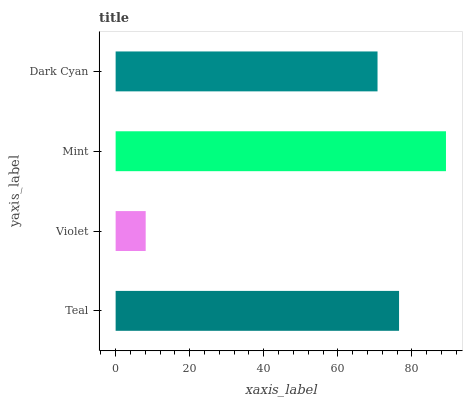Is Violet the minimum?
Answer yes or no. Yes. Is Mint the maximum?
Answer yes or no. Yes. Is Mint the minimum?
Answer yes or no. No. Is Violet the maximum?
Answer yes or no. No. Is Mint greater than Violet?
Answer yes or no. Yes. Is Violet less than Mint?
Answer yes or no. Yes. Is Violet greater than Mint?
Answer yes or no. No. Is Mint less than Violet?
Answer yes or no. No. Is Teal the high median?
Answer yes or no. Yes. Is Dark Cyan the low median?
Answer yes or no. Yes. Is Dark Cyan the high median?
Answer yes or no. No. Is Teal the low median?
Answer yes or no. No. 